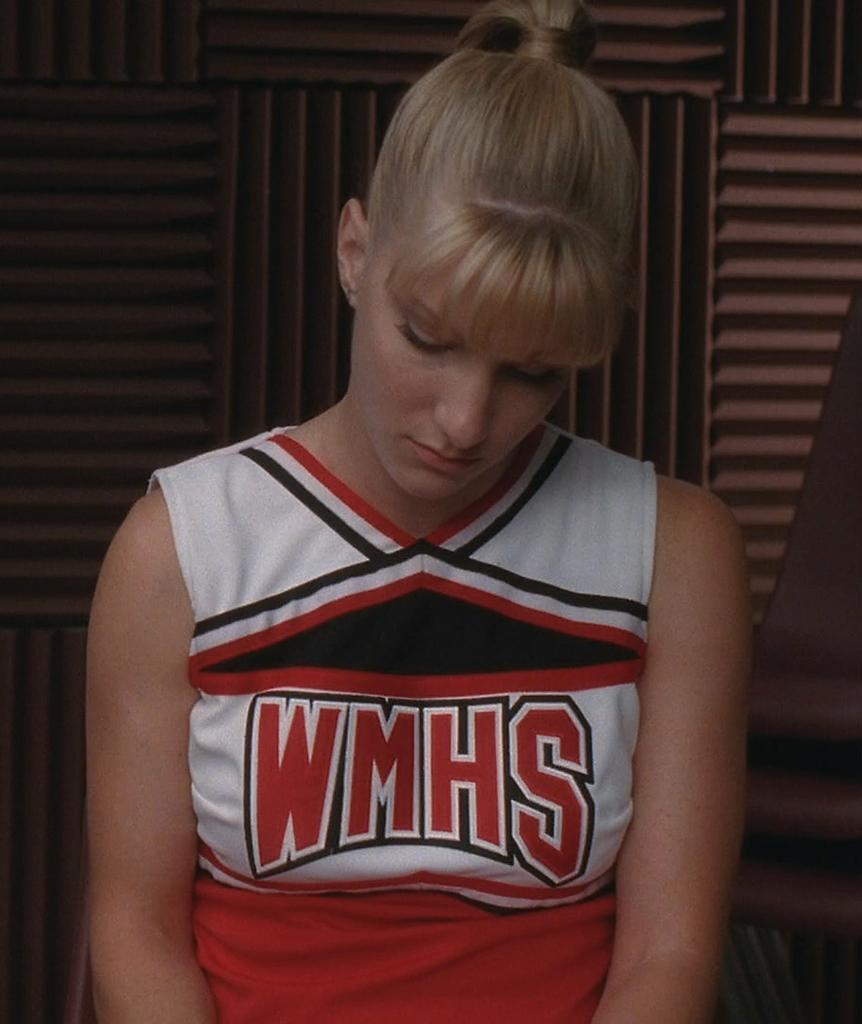Provide a one-sentence caption for the provided image. a cheerleader for WMHS in a red, white and black uniform. 